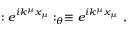Convert formula to latex. <formula><loc_0><loc_0><loc_500><loc_500>\colon e ^ { i k ^ { \mu } x _ { \mu } } \colon _ { \theta } \equiv e ^ { i k ^ { \mu } x _ { \mu } } ,</formula> 